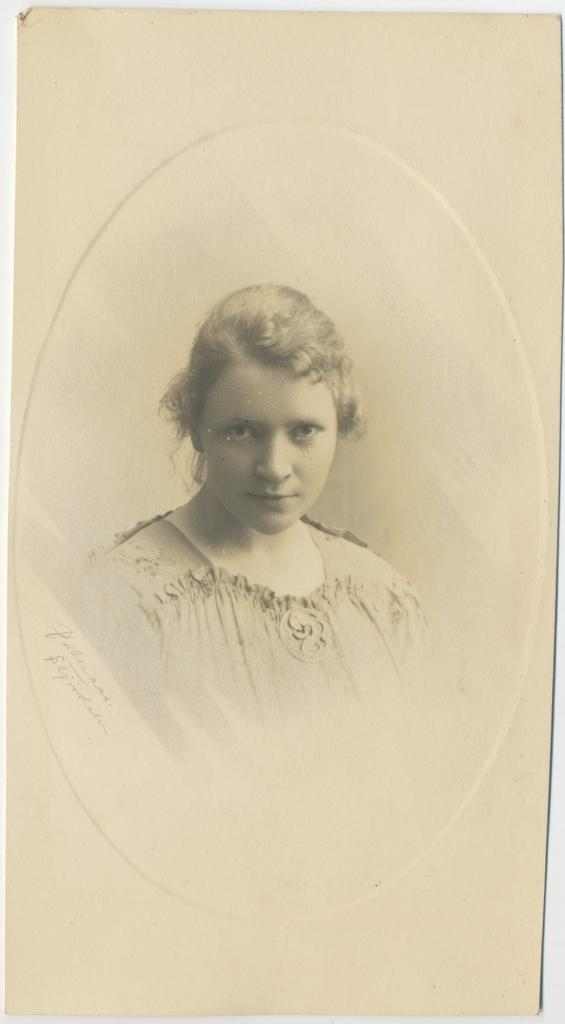What is depicted in the image? There is a sketch of a woman in the image. What medium is the sketch created on? The sketch is drawn on paper. How many toes can be seen in the sketch of the woman? There is no information about the woman's toes in the image, as it only shows a sketch of her. 